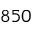<formula> <loc_0><loc_0><loc_500><loc_500>8 5 0</formula> 